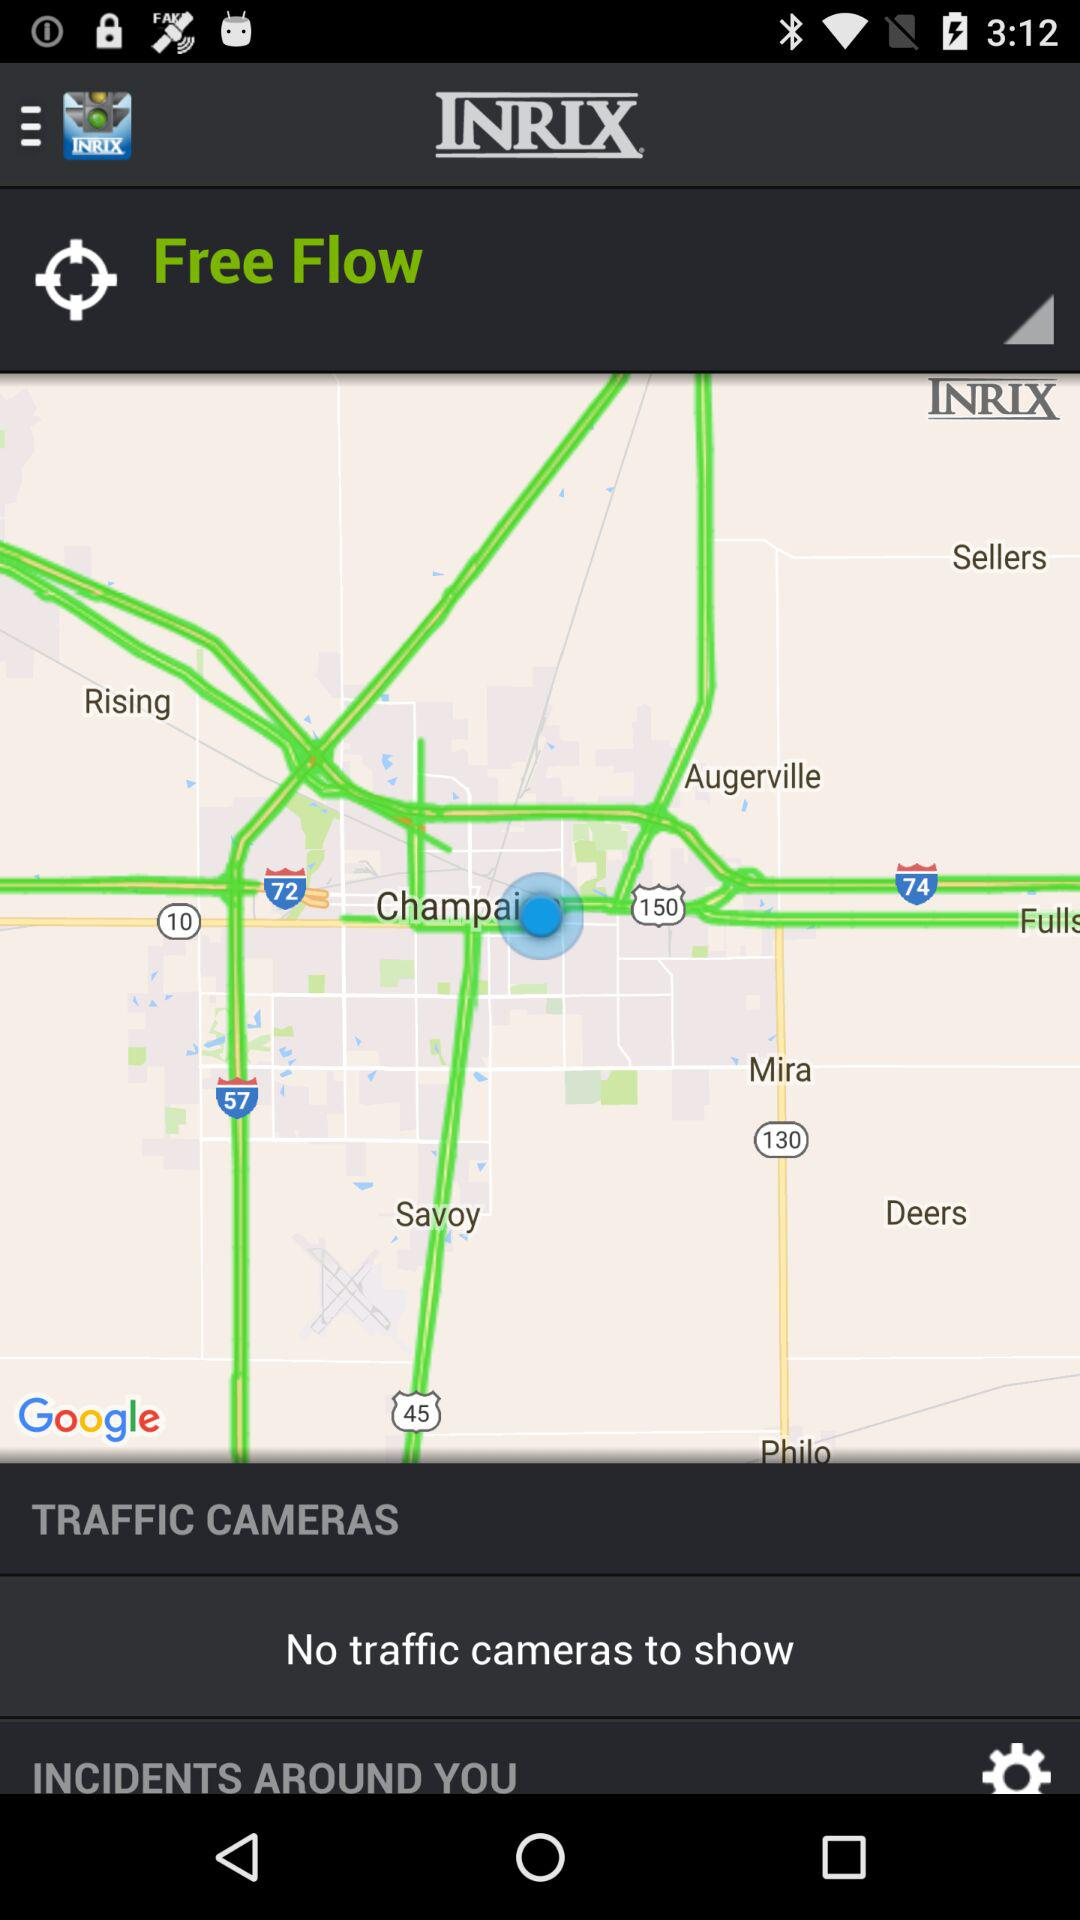What is the application name? The application name is "INRIX". 